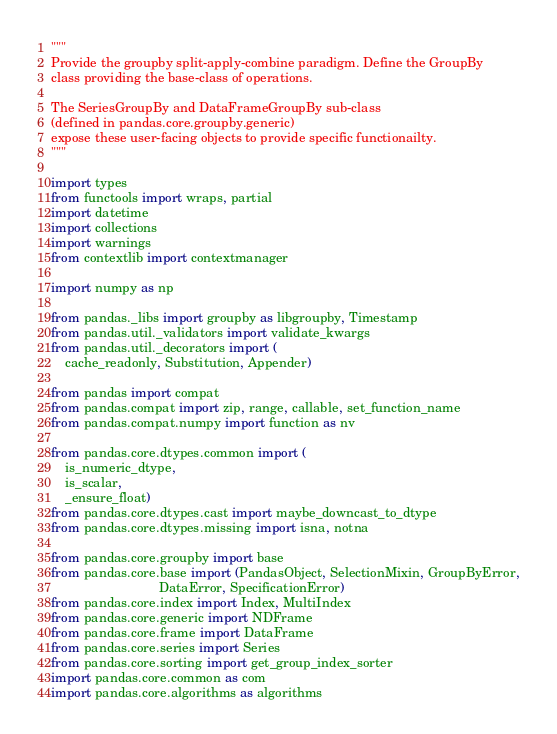<code> <loc_0><loc_0><loc_500><loc_500><_Python_>"""
Provide the groupby split-apply-combine paradigm. Define the GroupBy
class providing the base-class of operations.

The SeriesGroupBy and DataFrameGroupBy sub-class
(defined in pandas.core.groupby.generic)
expose these user-facing objects to provide specific functionailty.
"""

import types
from functools import wraps, partial
import datetime
import collections
import warnings
from contextlib import contextmanager

import numpy as np

from pandas._libs import groupby as libgroupby, Timestamp
from pandas.util._validators import validate_kwargs
from pandas.util._decorators import (
    cache_readonly, Substitution, Appender)

from pandas import compat
from pandas.compat import zip, range, callable, set_function_name
from pandas.compat.numpy import function as nv

from pandas.core.dtypes.common import (
    is_numeric_dtype,
    is_scalar,
    _ensure_float)
from pandas.core.dtypes.cast import maybe_downcast_to_dtype
from pandas.core.dtypes.missing import isna, notna

from pandas.core.groupby import base
from pandas.core.base import (PandasObject, SelectionMixin, GroupByError,
                              DataError, SpecificationError)
from pandas.core.index import Index, MultiIndex
from pandas.core.generic import NDFrame
from pandas.core.frame import DataFrame
from pandas.core.series import Series
from pandas.core.sorting import get_group_index_sorter
import pandas.core.common as com
import pandas.core.algorithms as algorithms</code> 